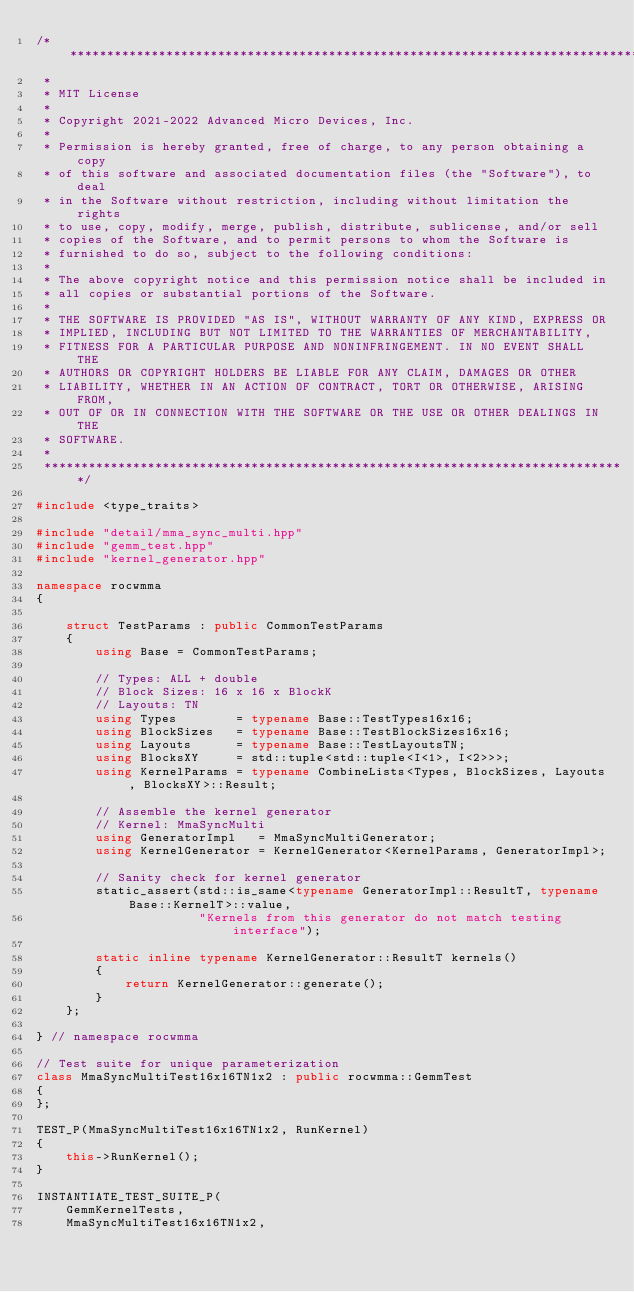Convert code to text. <code><loc_0><loc_0><loc_500><loc_500><_C++_>/*******************************************************************************
 *
 * MIT License
 *
 * Copyright 2021-2022 Advanced Micro Devices, Inc.
 *
 * Permission is hereby granted, free of charge, to any person obtaining a copy
 * of this software and associated documentation files (the "Software"), to deal
 * in the Software without restriction, including without limitation the rights
 * to use, copy, modify, merge, publish, distribute, sublicense, and/or sell
 * copies of the Software, and to permit persons to whom the Software is
 * furnished to do so, subject to the following conditions:
 *
 * The above copyright notice and this permission notice shall be included in
 * all copies or substantial portions of the Software.
 *
 * THE SOFTWARE IS PROVIDED "AS IS", WITHOUT WARRANTY OF ANY KIND, EXPRESS OR
 * IMPLIED, INCLUDING BUT NOT LIMITED TO THE WARRANTIES OF MERCHANTABILITY,
 * FITNESS FOR A PARTICULAR PURPOSE AND NONINFRINGEMENT. IN NO EVENT SHALL THE
 * AUTHORS OR COPYRIGHT HOLDERS BE LIABLE FOR ANY CLAIM, DAMAGES OR OTHER
 * LIABILITY, WHETHER IN AN ACTION OF CONTRACT, TORT OR OTHERWISE, ARISING FROM,
 * OUT OF OR IN CONNECTION WITH THE SOFTWARE OR THE USE OR OTHER DEALINGS IN THE
 * SOFTWARE.
 *
 *******************************************************************************/

#include <type_traits>

#include "detail/mma_sync_multi.hpp"
#include "gemm_test.hpp"
#include "kernel_generator.hpp"

namespace rocwmma
{

    struct TestParams : public CommonTestParams
    {
        using Base = CommonTestParams;

        // Types: ALL + double
        // Block Sizes: 16 x 16 x BlockK
        // Layouts: TN
        using Types        = typename Base::TestTypes16x16;
        using BlockSizes   = typename Base::TestBlockSizes16x16;
        using Layouts      = typename Base::TestLayoutsTN;
        using BlocksXY     = std::tuple<std::tuple<I<1>, I<2>>>;
        using KernelParams = typename CombineLists<Types, BlockSizes, Layouts, BlocksXY>::Result;

        // Assemble the kernel generator
        // Kernel: MmaSyncMulti
        using GeneratorImpl   = MmaSyncMultiGenerator;
        using KernelGenerator = KernelGenerator<KernelParams, GeneratorImpl>;

        // Sanity check for kernel generator
        static_assert(std::is_same<typename GeneratorImpl::ResultT, typename Base::KernelT>::value,
                      "Kernels from this generator do not match testing interface");

        static inline typename KernelGenerator::ResultT kernels()
        {
            return KernelGenerator::generate();
        }
    };

} // namespace rocwmma

// Test suite for unique parameterization
class MmaSyncMultiTest16x16TN1x2 : public rocwmma::GemmTest
{
};

TEST_P(MmaSyncMultiTest16x16TN1x2, RunKernel)
{
    this->RunKernel();
}

INSTANTIATE_TEST_SUITE_P(
    GemmKernelTests,
    MmaSyncMultiTest16x16TN1x2,</code> 